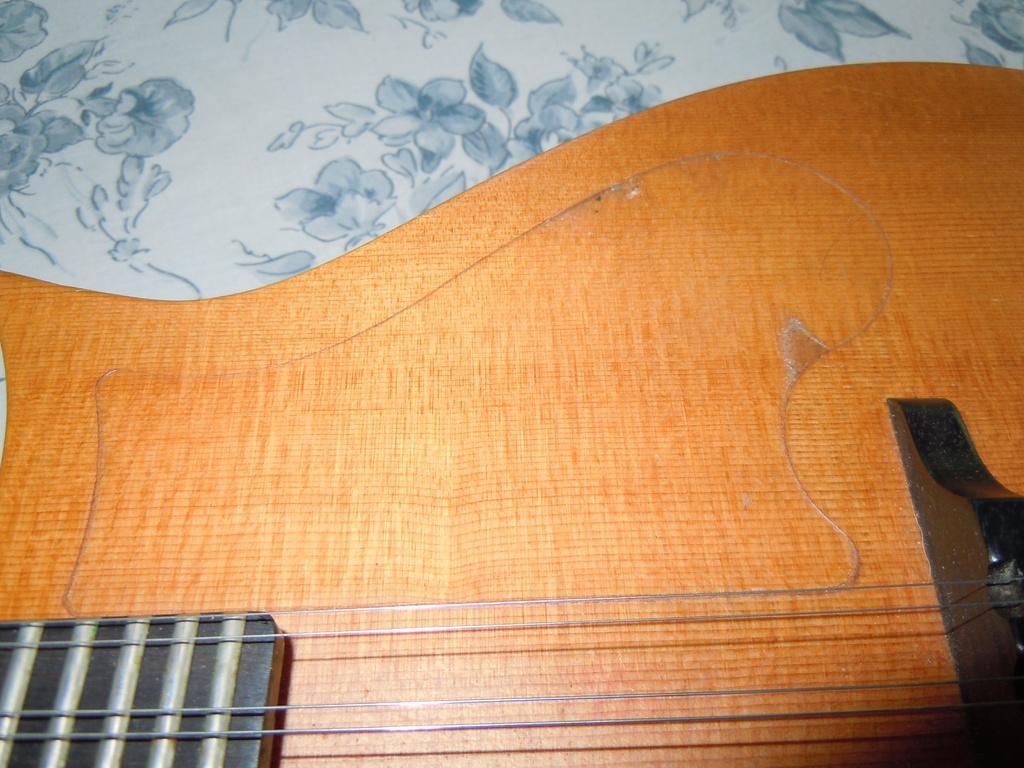Could you give a brief overview of what you see in this image? There is a guitar on table. 